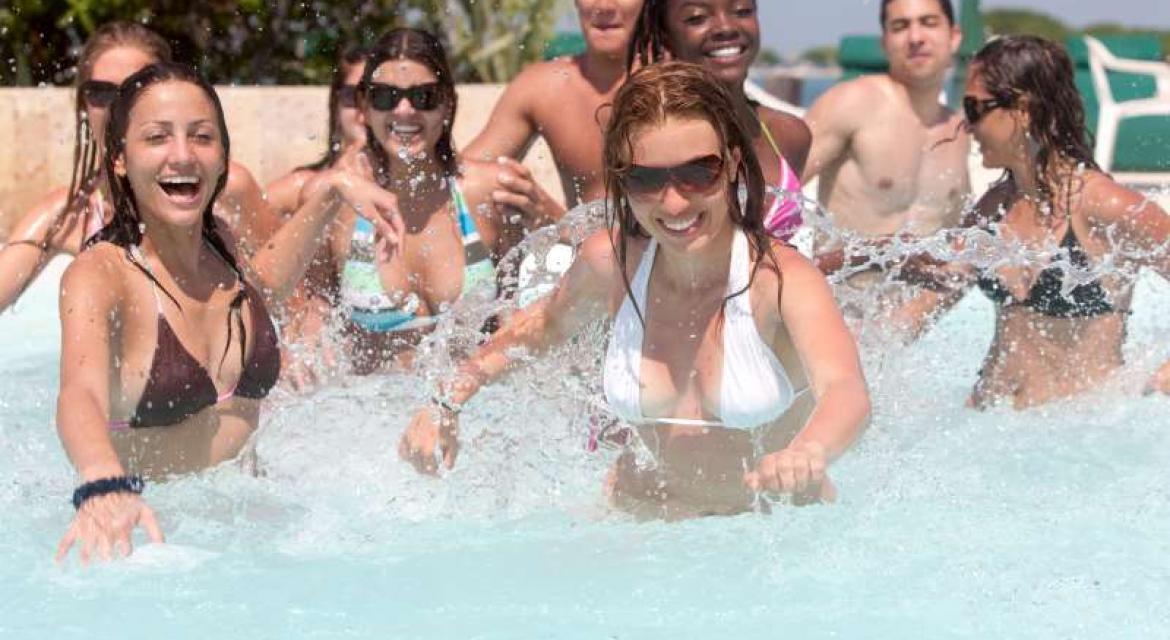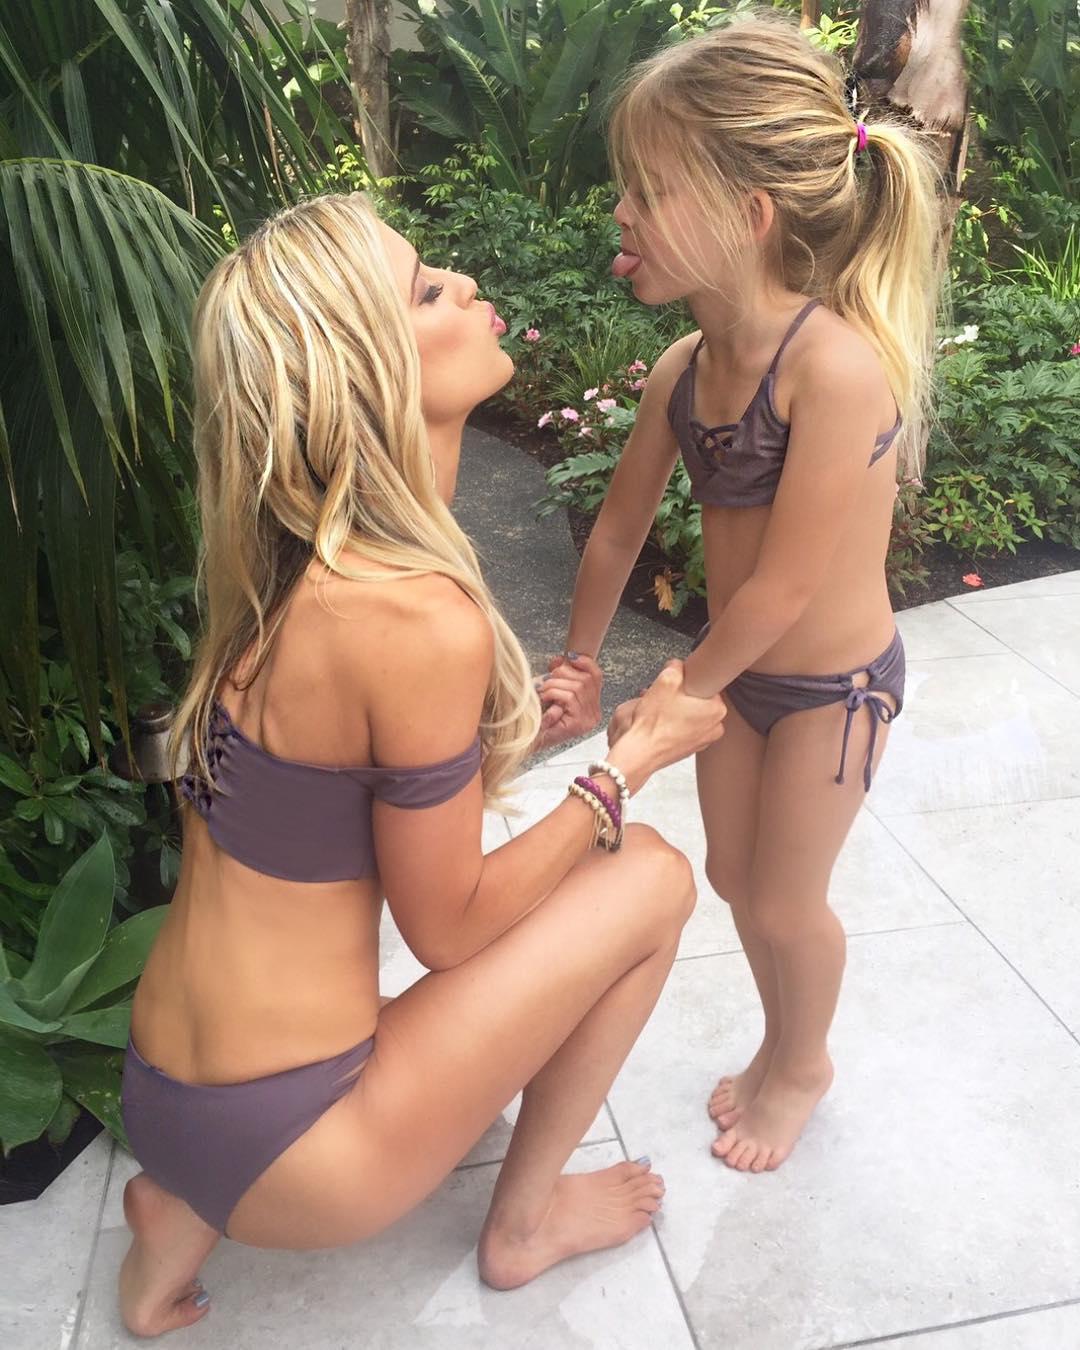The first image is the image on the left, the second image is the image on the right. For the images shown, is this caption "A woman is wearing a predominantly orange swimsuit and denim shorts." true? Answer yes or no. No. The first image is the image on the left, the second image is the image on the right. For the images shown, is this caption "An image shows one model wearing a twisted bikini top and denim shorts." true? Answer yes or no. No. 